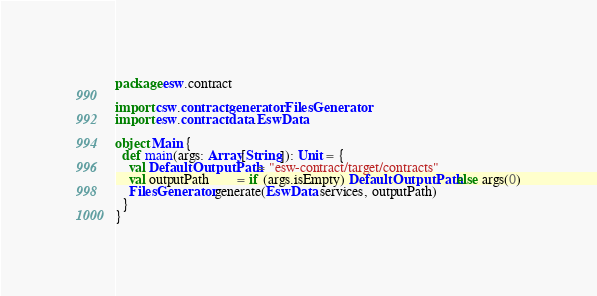Convert code to text. <code><loc_0><loc_0><loc_500><loc_500><_Scala_>package esw.contract

import csw.contract.generator.FilesGenerator
import esw.contract.data.EswData

object Main {
  def main(args: Array[String]): Unit = {
    val DefaultOutputPath = "esw-contract/target/contracts"
    val outputPath        = if (args.isEmpty) DefaultOutputPath else args(0)
    FilesGenerator.generate(EswData.services, outputPath)
  }
}
</code> 